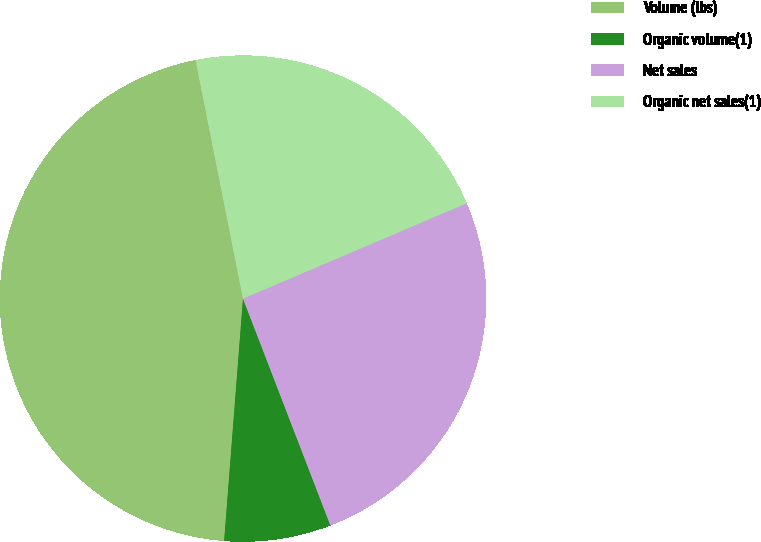Convert chart. <chart><loc_0><loc_0><loc_500><loc_500><pie_chart><fcel>Volume (lbs)<fcel>Organic volume(1)<fcel>Net sales<fcel>Organic net sales(1)<nl><fcel>45.64%<fcel>7.09%<fcel>25.56%<fcel>21.71%<nl></chart> 